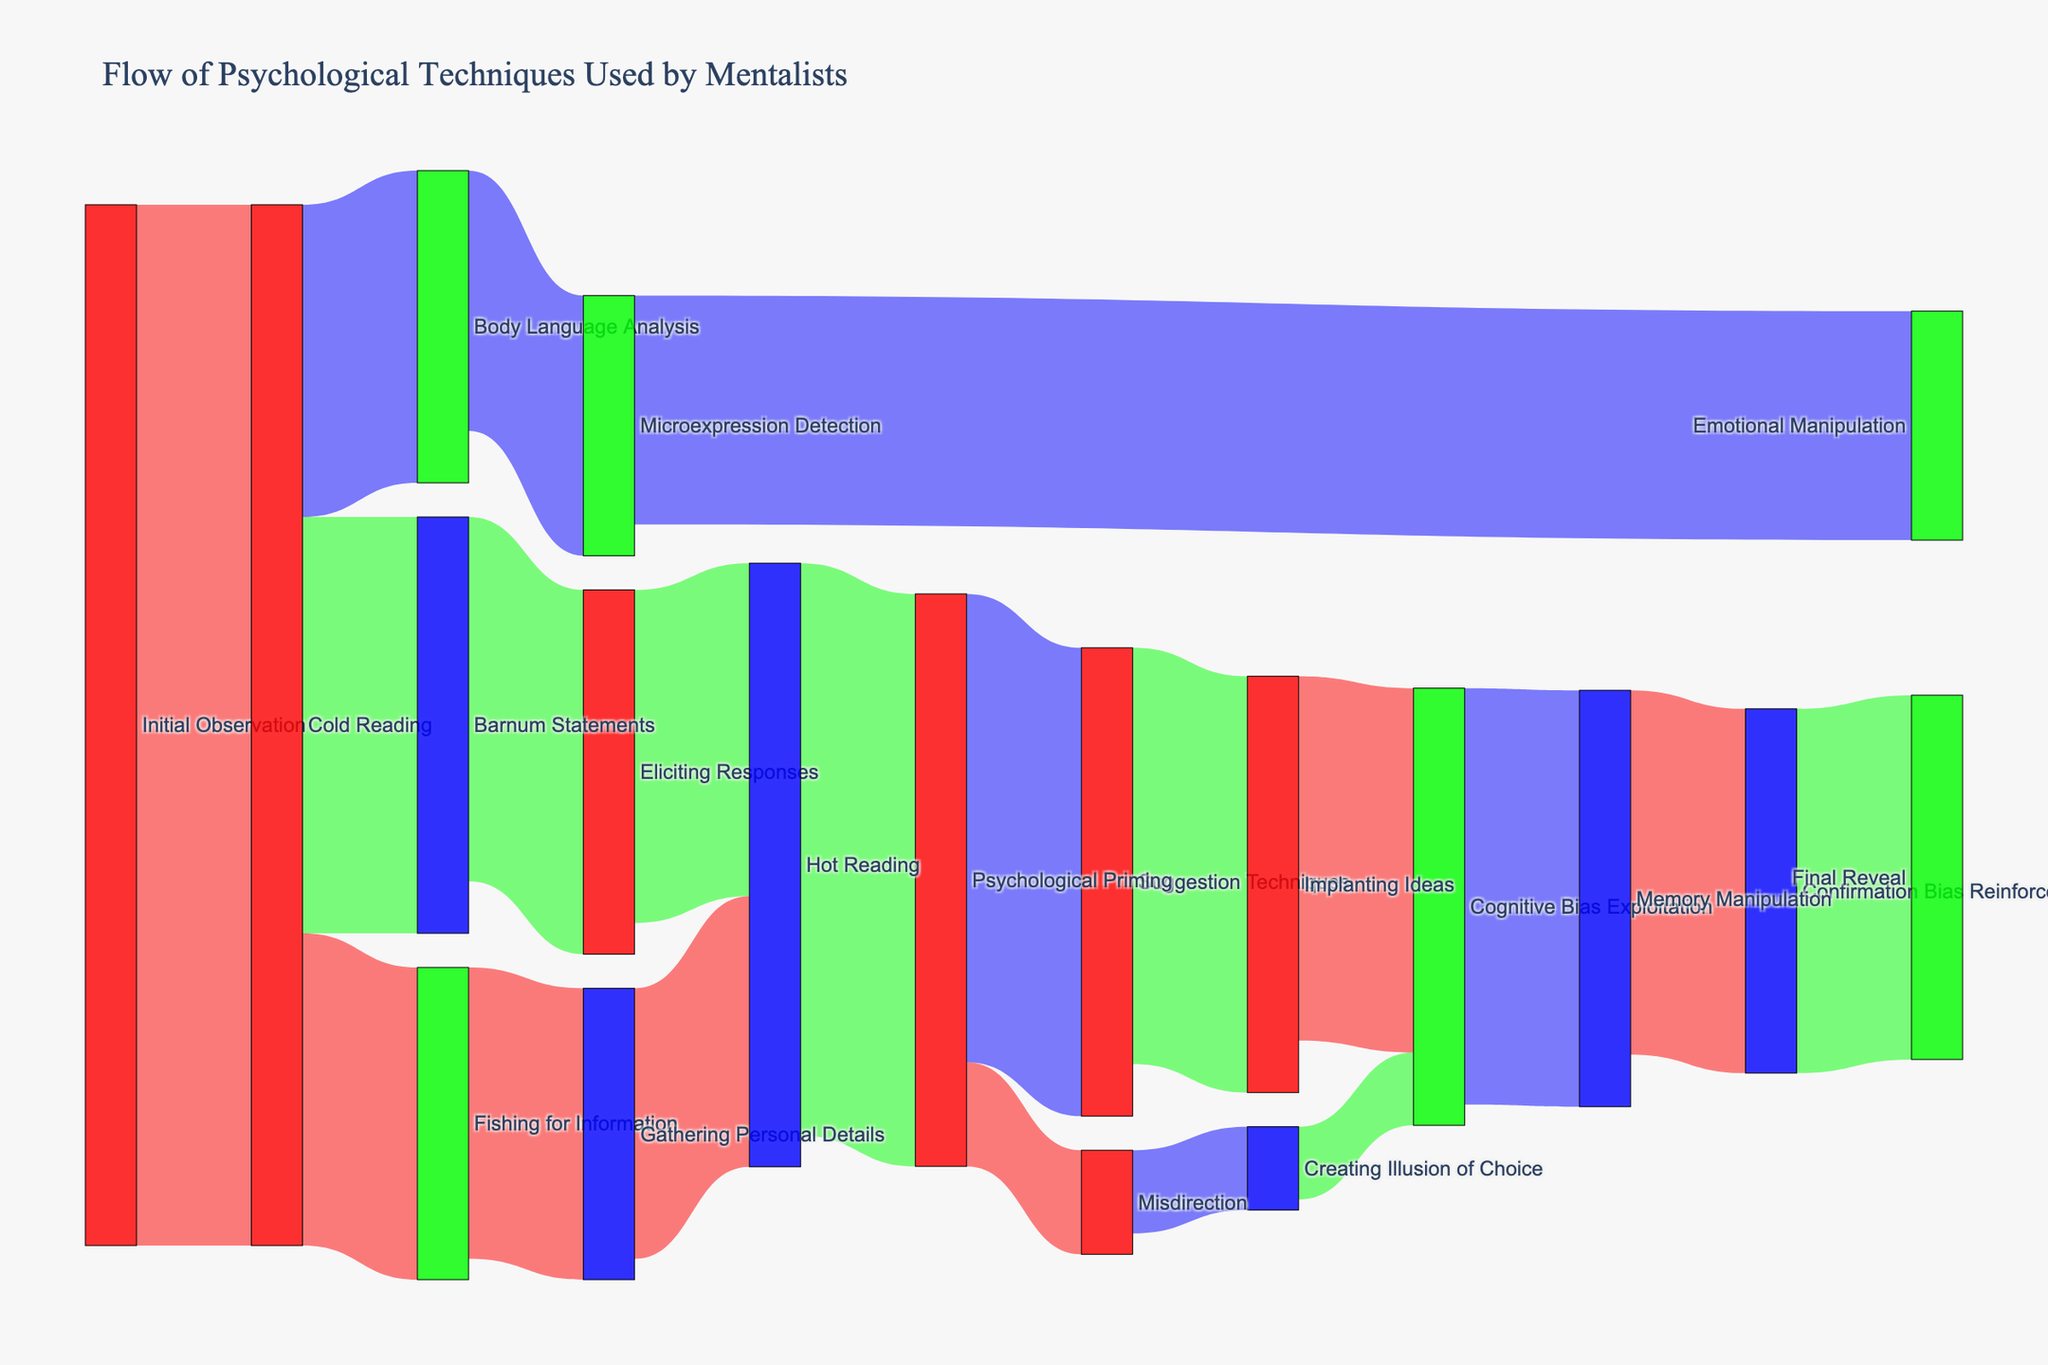what's the title of the figure? The title is usually found at the top of the figure. Here, it should provide an overview of the content. The title of this Sankey diagram is "Flow of Psychological Techniques Used by Mentalists."
Answer: Flow of Psychological Techniques Used by Mentalists Which technique has the highest flow value from Cold Reading? From Cold Reading, we have flows to Barnum Statements (40), Body Language Analysis (30), and Fishing for Information (30). The highest value is from Cold Reading to Barnum Statements, which has a value of 40.
Answer: Barnum Statements What’s the total value flowing into Hot Reading? Hot Reading receives inputs from Eliciting Responses (32) and Gathering Personal Details (26). Adding these values, 32 + 26 = 58.
Answer: 58 Which is greater: Psychological Priming to Suggestion Techniques or Psychological Priming to Misdirection? Psychological Priming to Suggestion Techniques is 45, and Psychological Priming to Misdirection is 10. Since 45 is greater than 10, Psychological Priming to Suggestion Techniques is the greater flow.
Answer: Psychological Priming to Suggestion Techniques What is the final technique in the flow? The final technique in the flow, as indicated by the last target in the chart, is the Final Reveal.
Answer: Final Reveal How many techniques does Cognitive Bias Exploitation receive input from? To identify how many techniques flow into Cognitive Bias Exploitation, we look at the links coming into it. We have flows from Implanting Ideas and Creating Illusion of Choice, giving us a total of two techniques.
Answer: 2 What's the total value flowing out from Psychological Priming? Psychological Priming flows out to Suggestion Techniques (45) and Misdirection (10). Summing these, 45 + 10 = 55.
Answer: 55 Which technique directly leads to the Final Reveal? The technique directly leading to the Final Reveal is Confirmation Bias Reinforcement, as shown by the final link.
Answer: Confirmation Bias Reinforcement What is the cumulative value starting from Cold Reading and ending at Final Reveal, passing through Hot Reading and Confirmation Bias Reinforcement? First, determine the values in the pathway. Cold Reading to Hot Reading through Barnum Statements and Eliciting Responses is: Cold Reading to Barnum Statements (40) + Barnum Statements to Eliciting Responses (35) + Eliciting Responses to Hot Reading (32) is 107. Then, we have Hot Reading to Psychological Priming (55) + Psychological Priming to Suggestion Techniques (45) + Suggestion Techniques to Implanting Ideas (40) + Implanting Ideas to Cognitive Bias Exploitation (35) + Cognitive Bias Exploitation to Memory Manipulation (40) + Memory Manipulation to Confirmation Bias Reinforcement (35) + Confirmation Bias Reinforcement to Final Reveal (35), which is 115 + 120. Hence the cumulative value is 107 + 155 + 120 and = 382.
Answer: 382 